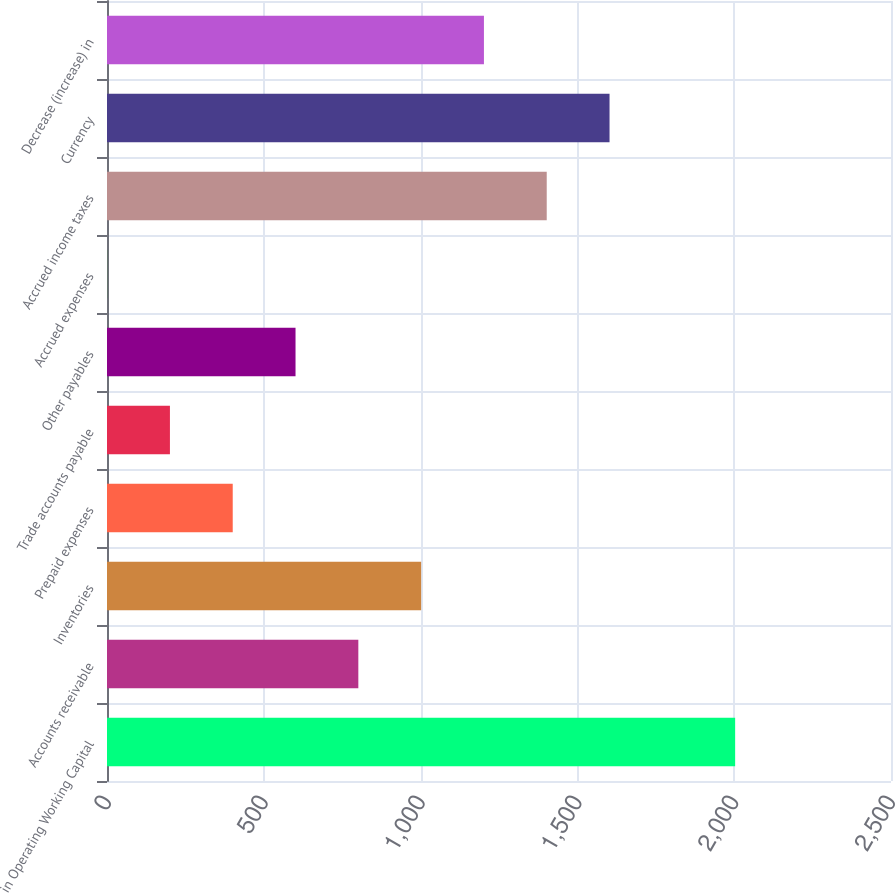<chart> <loc_0><loc_0><loc_500><loc_500><bar_chart><fcel>in Operating Working Capital<fcel>Accounts receivable<fcel>Inventories<fcel>Prepaid expenses<fcel>Trade accounts payable<fcel>Other payables<fcel>Accrued expenses<fcel>Accrued income taxes<fcel>Currency<fcel>Decrease (increase) in<nl><fcel>2003<fcel>801.44<fcel>1001.7<fcel>400.92<fcel>200.66<fcel>601.18<fcel>0.4<fcel>1402.22<fcel>1602.48<fcel>1201.96<nl></chart> 